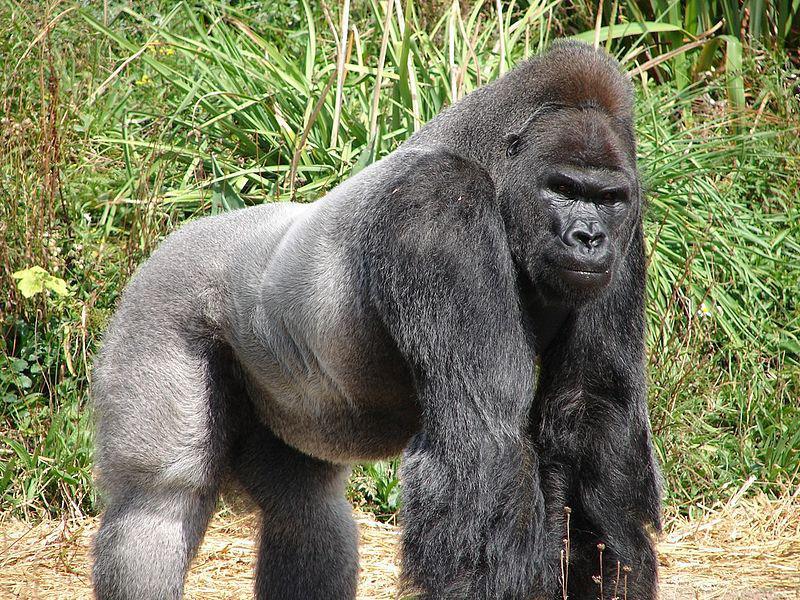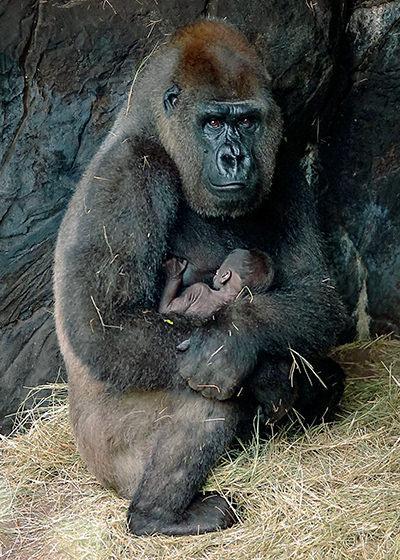The first image is the image on the left, the second image is the image on the right. Evaluate the accuracy of this statement regarding the images: "Exactly one of the ape's feet can be seen in the image on the right.". Is it true? Answer yes or no. Yes. 